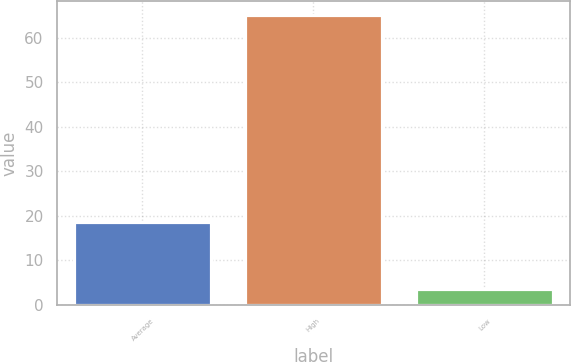<chart> <loc_0><loc_0><loc_500><loc_500><bar_chart><fcel>Average<fcel>High<fcel>Low<nl><fcel>18.5<fcel>65<fcel>3.6<nl></chart> 